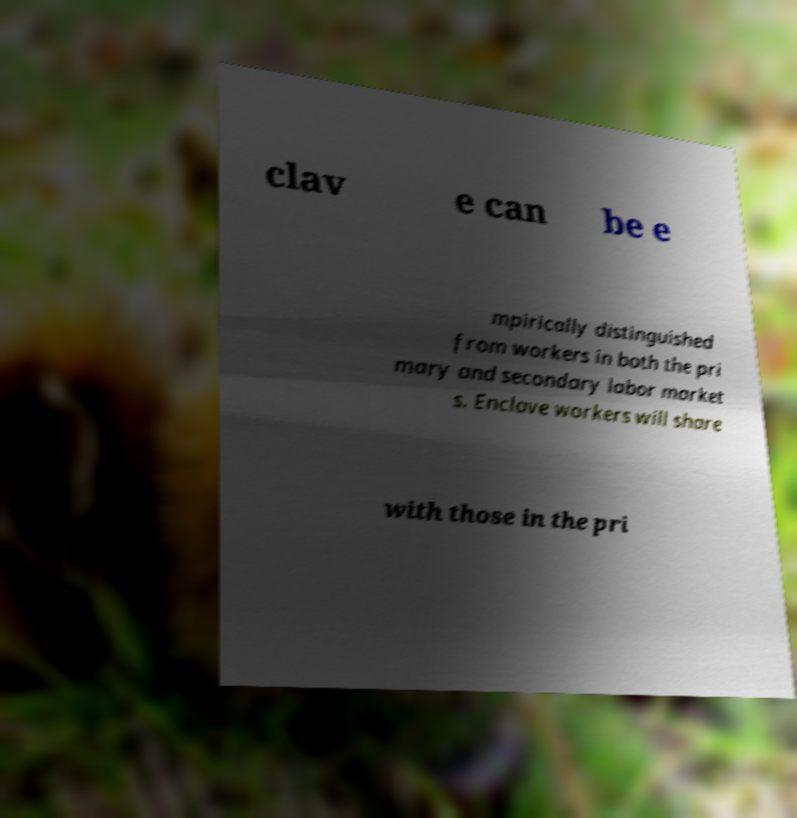Could you assist in decoding the text presented in this image and type it out clearly? clav e can be e mpirically distinguished from workers in both the pri mary and secondary labor market s. Enclave workers will share with those in the pri 